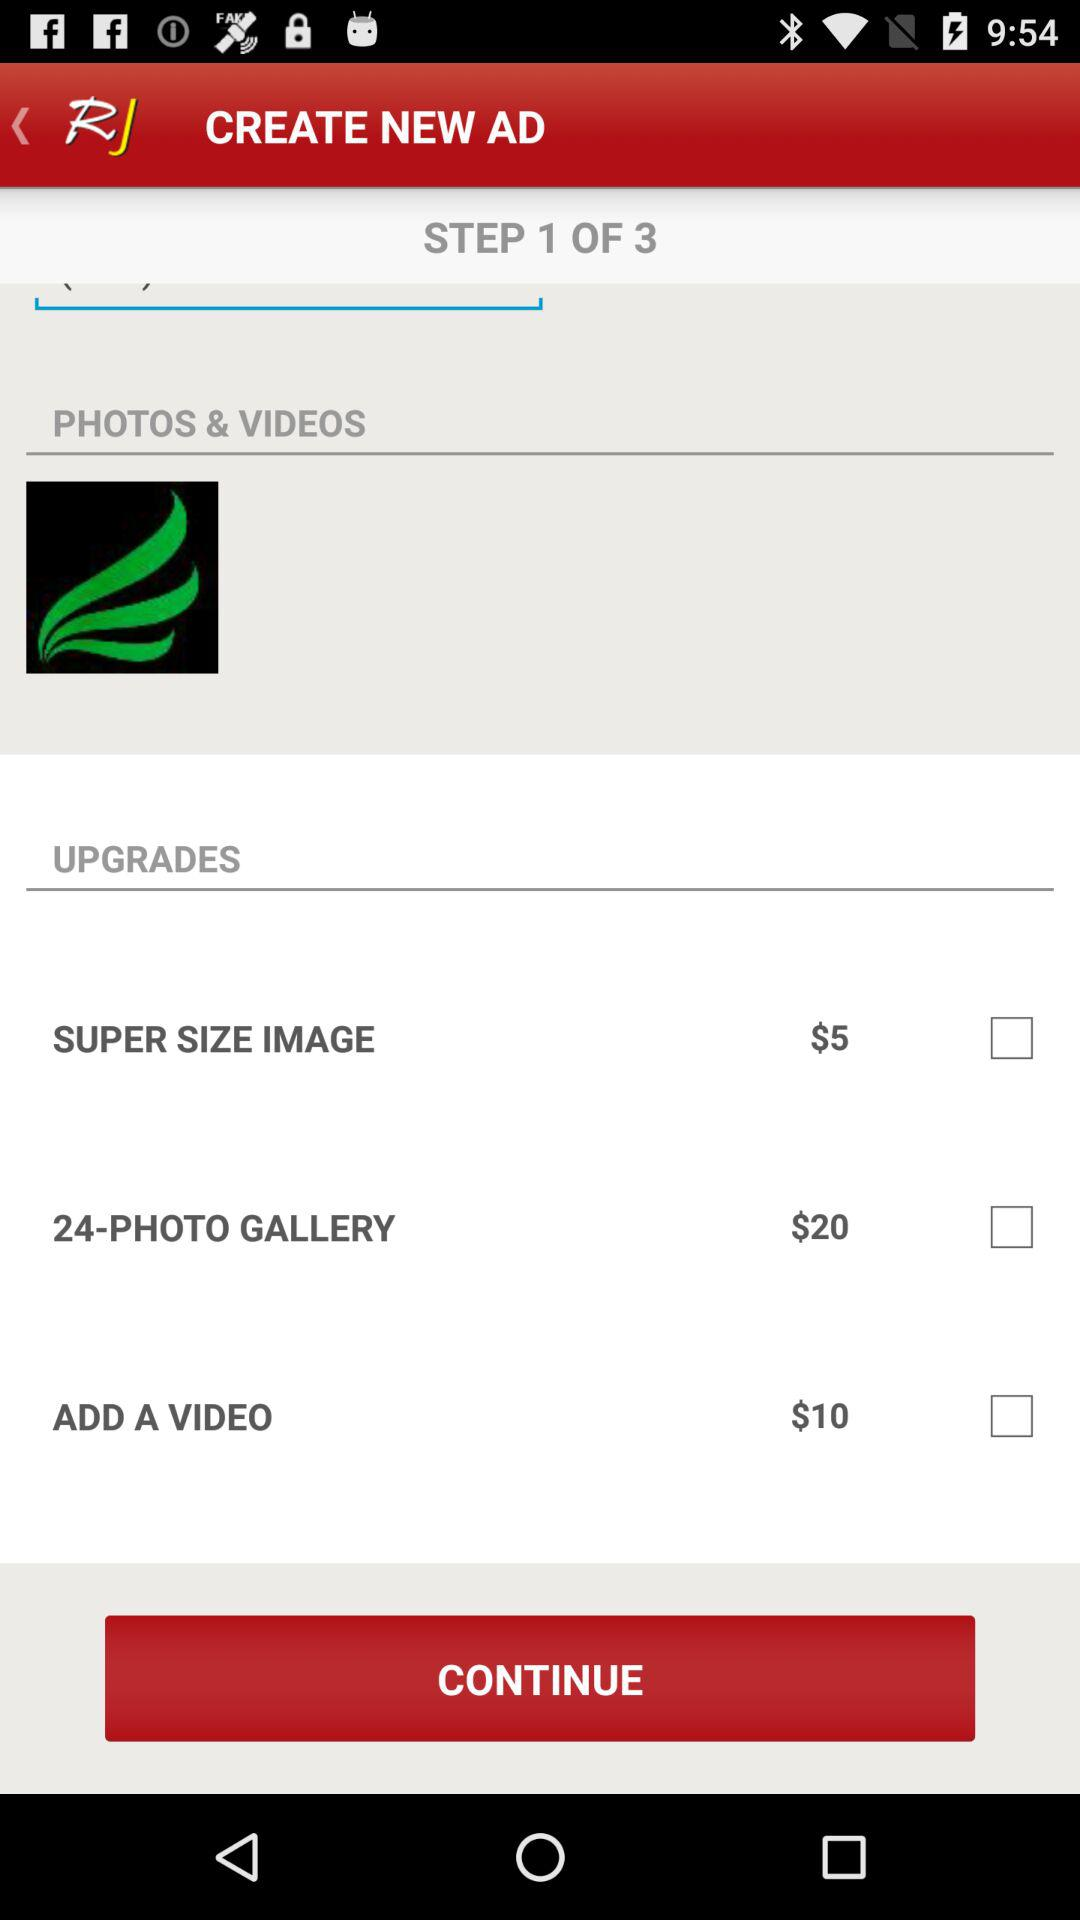At what step am I? You are on step 1. 